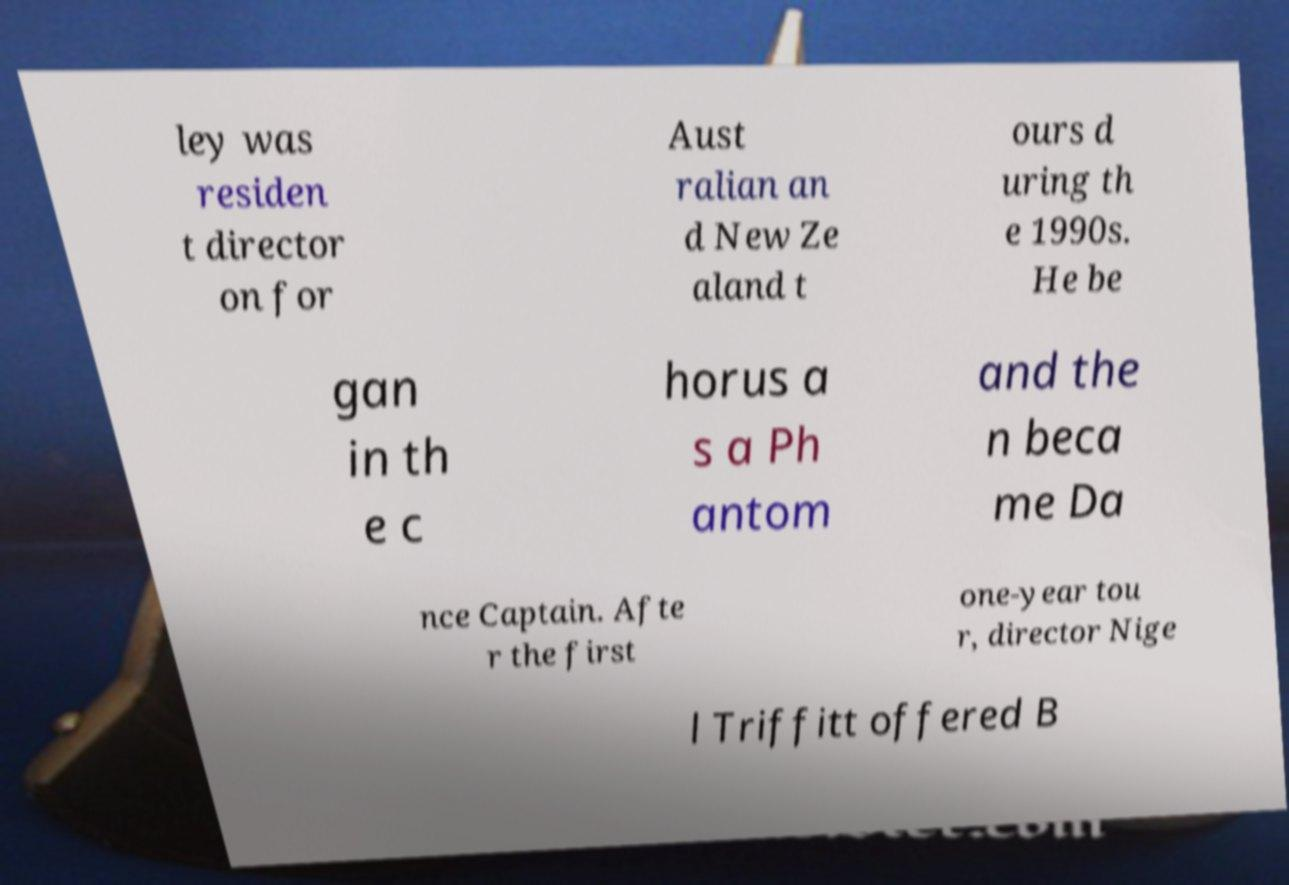Please identify and transcribe the text found in this image. ley was residen t director on for Aust ralian an d New Ze aland t ours d uring th e 1990s. He be gan in th e c horus a s a Ph antom and the n beca me Da nce Captain. Afte r the first one-year tou r, director Nige l Triffitt offered B 